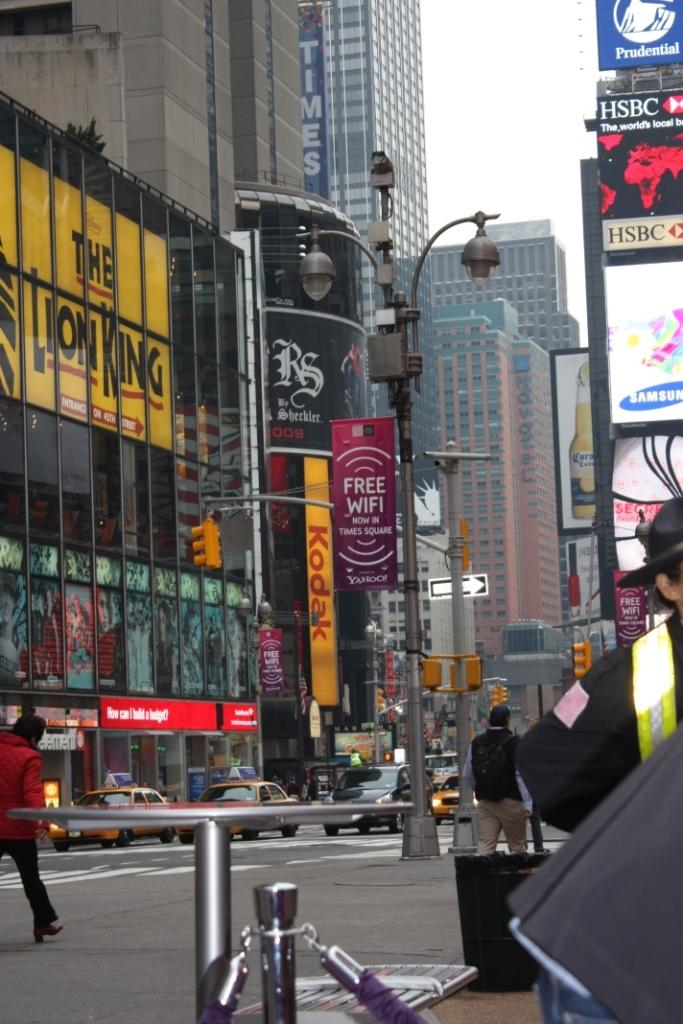Who or what can be seen in the image? There are people in the image. What type of structures are visible in the image? There are buildings with windows in the image. What additional items can be seen in the image? There are posters, poles, lights, and sign boards in the image. What part of the natural environment is visible in the image? The sky is visible in the image. What type of table is being used by the band in the image? There is no band present in the image, so there is no table being used by a band. 